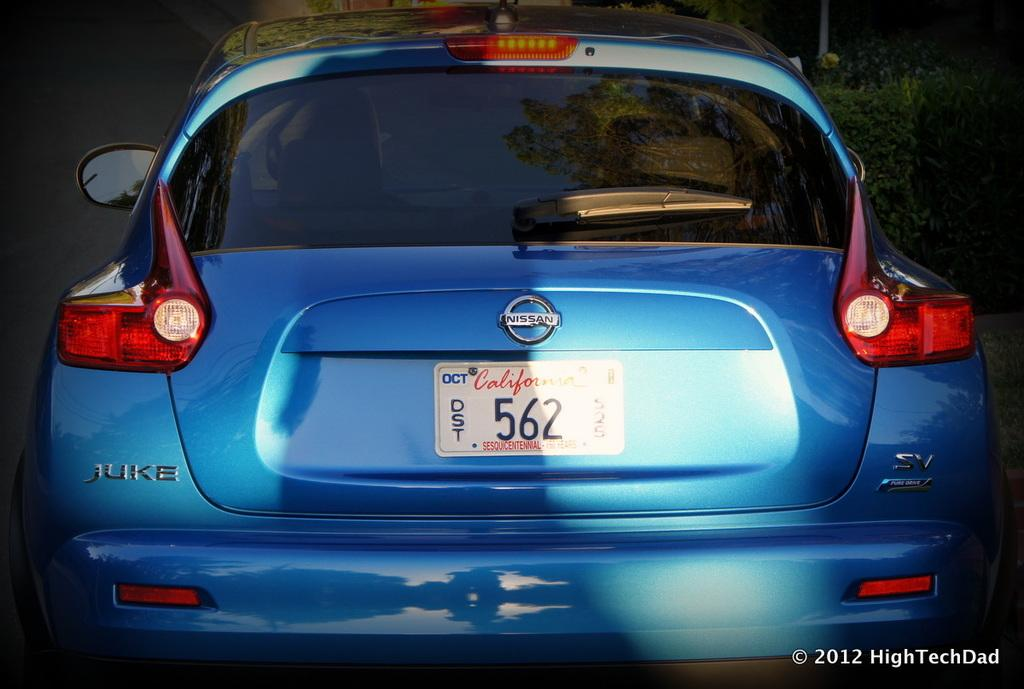<image>
Relay a brief, clear account of the picture shown. the numbers 562 that is on a license plate 